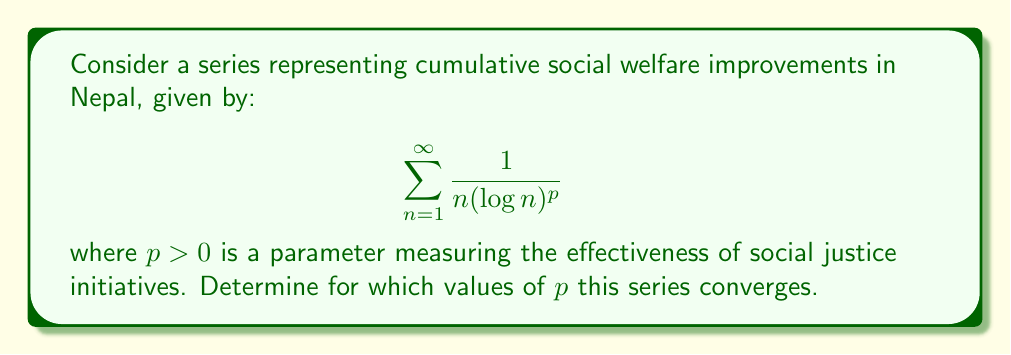Can you solve this math problem? To determine the convergence of this series, we can use the integral test. Let's define:

$$f(x) = \frac{1}{x(\log x)^p}$$

1) First, we need to check if $f(x)$ is continuous, positive, and decreasing for $x \geq 2$:
   - $f(x)$ is continuous for $x > 1$
   - $f(x)$ is positive for $x > 1$
   - $f'(x) = -\frac{1}{x^2(\log x)^p} - \frac{p}{x^2(\log x)^{p+1}} < 0$ for $x > 1$, so $f(x)$ is decreasing

2) Now, we can apply the integral test. The series converges if and only if the following improper integral converges:

   $$\int_2^{\infty} \frac{1}{x(\log x)^p} dx$$

3) Let's solve this integral:
   
   Let $u = \log x$, then $du = \frac{1}{x}dx$
   
   $$\int_2^{\infty} \frac{1}{x(\log x)^p} dx = \int_{\log 2}^{\infty} \frac{1}{u^p} du$$

4) This is a p-integral. It converges if and only if $p > 1$. When $p > 1$:

   $$\int_{\log 2}^{\infty} \frac{1}{u^p} du = \left[-\frac{1}{(p-1)u^{p-1}}\right]_{\log 2}^{\infty} = \frac{1}{(p-1)(\log 2)^{p-1}}$$

5) Therefore, by the integral test, the original series converges if and only if $p > 1$.
Answer: The series $\sum_{n=1}^{\infty} \frac{1}{n(\log n)^p}$ converges if and only if $p > 1$. 